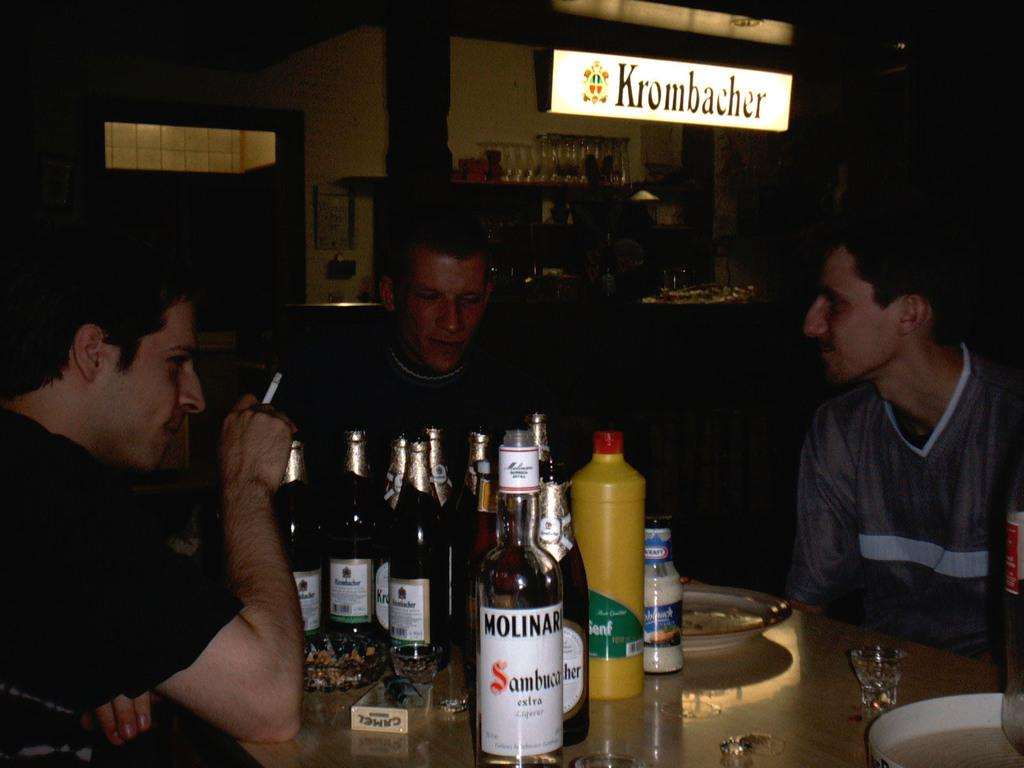How many men are sitting in the chairs in the image? There are three men sitting in chairs in the image. What are the chairs near in the image? The chairs are near a table in the image. What can be found on the table in the image? There are wine bottles, a plate, and glasses on the table in the image. What can be seen in the background of the image? There is a name board and a door in the background of the image. What type of acoustics can be heard in the image? There is no information about the acoustics in the image, as it only shows three men sitting in chairs, a table with wine bottles, a plate, and glasses, and a name board and door in the background. Can you tell me what time of day it is in the image based on the hour? There is no information about the time of day or hour in the image. 